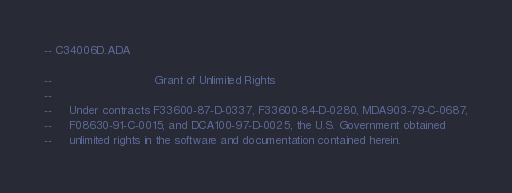<code> <loc_0><loc_0><loc_500><loc_500><_Ada_>-- C34006D.ADA

--                             Grant of Unlimited Rights
--
--     Under contracts F33600-87-D-0337, F33600-84-D-0280, MDA903-79-C-0687,
--     F08630-91-C-0015, and DCA100-97-D-0025, the U.S. Government obtained 
--     unlimited rights in the software and documentation contained herein.</code> 